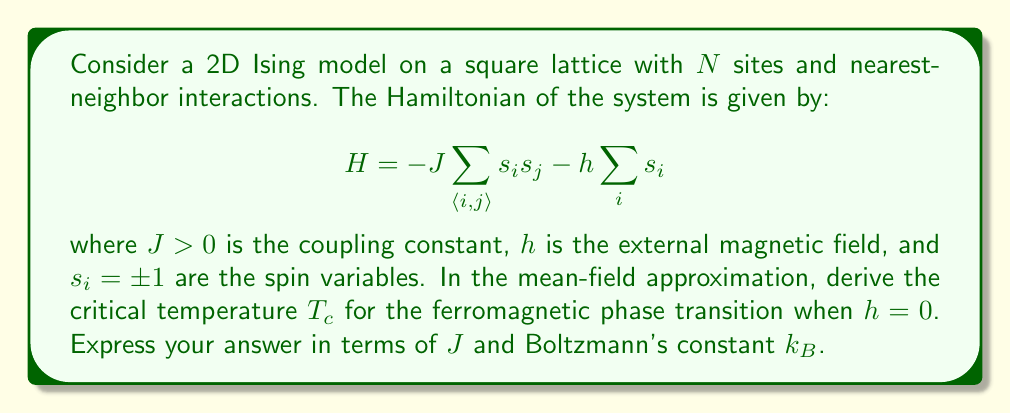Solve this math problem. To solve this problem, we'll use the mean-field approximation and follow these steps:

1) In the mean-field theory, we replace the spin-spin interaction term with an average field:
   $$s_i s_j \approx s_i \langle s \rangle + s_j \langle s \rangle - \langle s \rangle^2$$
   where $\langle s \rangle$ is the average spin.

2) The Hamiltonian becomes:
   $$H_{MF} = -JZ\langle s \rangle \sum_i s_i + \frac{1}{2}NJZ\langle s \rangle^2 - h\sum_i s_i$$
   where $Z$ is the coordination number (number of nearest neighbors, 4 for a 2D square lattice).

3) The effective field acting on each spin is:
   $$h_{eff} = JZ\langle s \rangle + h$$

4) In equilibrium, the average spin is given by:
   $$\langle s \rangle = \tanh(\beta h_{eff}) = \tanh(\beta JZ\langle s \rangle + \beta h)$$
   where $\beta = 1/(k_B T)$.

5) For $h = 0$, this becomes:
   $$\langle s \rangle = \tanh(\beta JZ\langle s \rangle)$$

6) Near the critical point, $\langle s \rangle$ is small, so we can expand the tanh:
   $$\langle s \rangle \approx \beta JZ\langle s \rangle - \frac{1}{3}(\beta JZ\langle s \rangle)^3 + ...$$

7) The critical temperature is where the linear term equals 1:
   $$1 = \beta_c JZ = \frac{JZ}{k_B T_c}$$

8) Solving for $T_c$:
   $$T_c = \frac{JZ}{k_B}$$

9) For a 2D square lattice, $Z = 4$, so the final result is:
   $$T_c = \frac{4J}{k_B}$$
Answer: $T_c = \frac{4J}{k_B}$ 